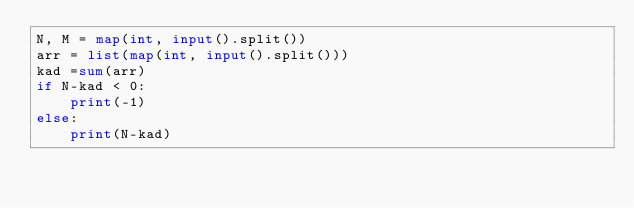Convert code to text. <code><loc_0><loc_0><loc_500><loc_500><_Python_>N, M = map(int, input().split())
arr = list(map(int, input().split()))
kad =sum(arr)
if N-kad < 0:
    print(-1)
else:
    print(N-kad)

</code> 